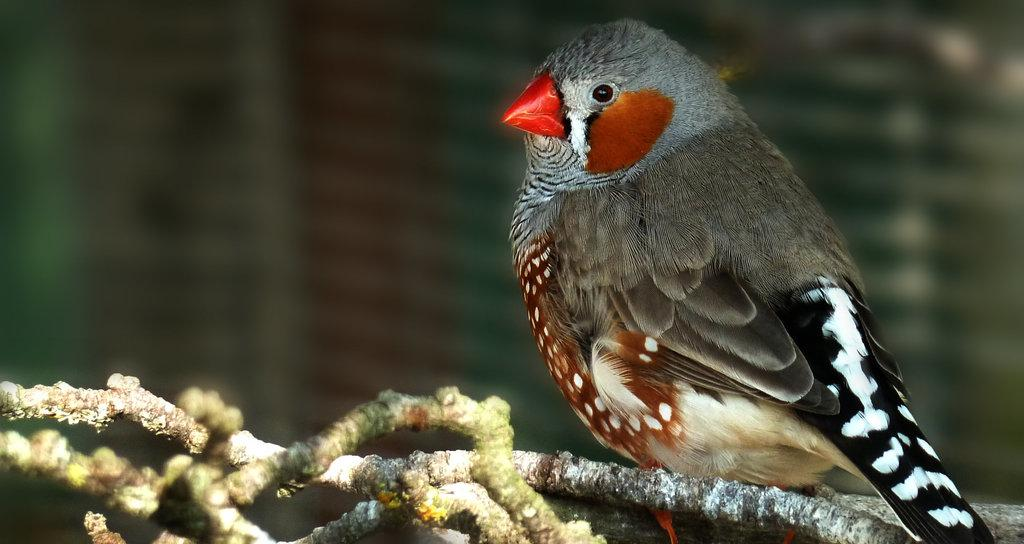What is located in the foreground towards the right in the image? There is a bird in the foreground towards the right in the image. What else can be seen in the foreground? There are stems of a tree in the foreground. How would you describe the background of the image? The background of the image is blurred. What type of iron can be seen in the image? There is no iron present in the image. How many worms are visible in the image? There are no worms visible in the image. 